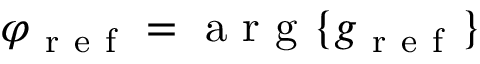Convert formula to latex. <formula><loc_0><loc_0><loc_500><loc_500>\varphi _ { r e f } = a r g \{ g _ { r e f } \}</formula> 